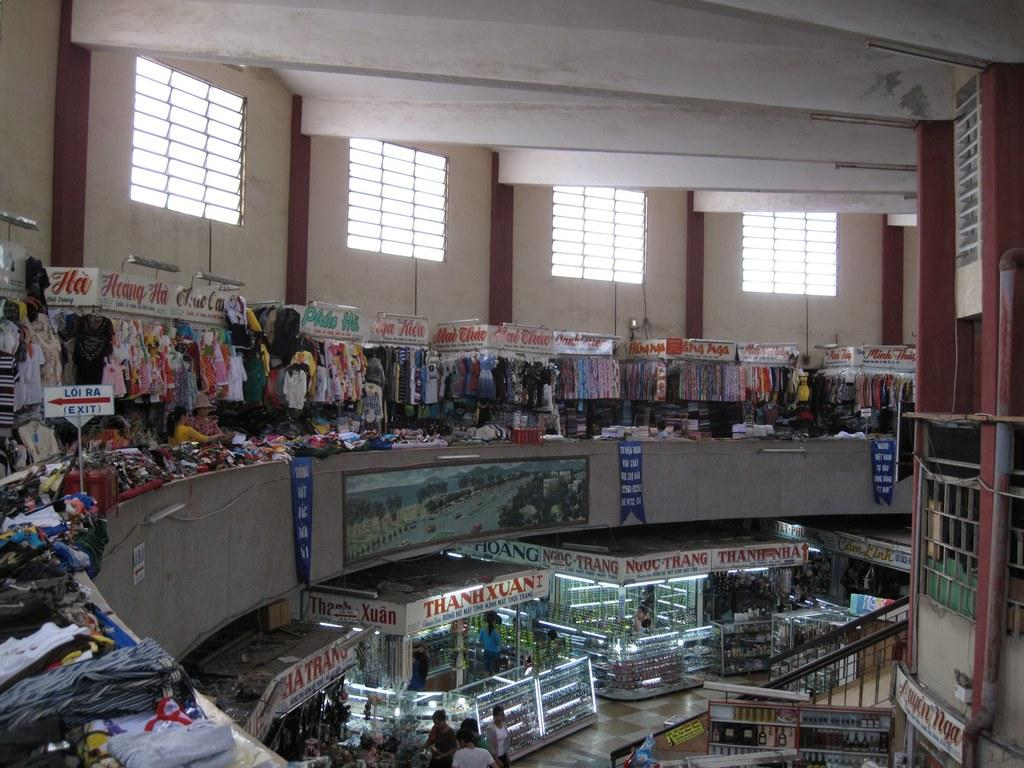<image>
Write a terse but informative summary of the picture. Various small shops inside a building like Thanh Xuan 